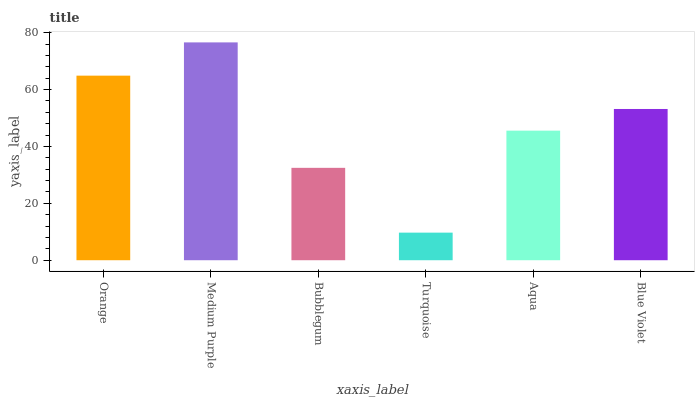Is Turquoise the minimum?
Answer yes or no. Yes. Is Medium Purple the maximum?
Answer yes or no. Yes. Is Bubblegum the minimum?
Answer yes or no. No. Is Bubblegum the maximum?
Answer yes or no. No. Is Medium Purple greater than Bubblegum?
Answer yes or no. Yes. Is Bubblegum less than Medium Purple?
Answer yes or no. Yes. Is Bubblegum greater than Medium Purple?
Answer yes or no. No. Is Medium Purple less than Bubblegum?
Answer yes or no. No. Is Blue Violet the high median?
Answer yes or no. Yes. Is Aqua the low median?
Answer yes or no. Yes. Is Orange the high median?
Answer yes or no. No. Is Medium Purple the low median?
Answer yes or no. No. 